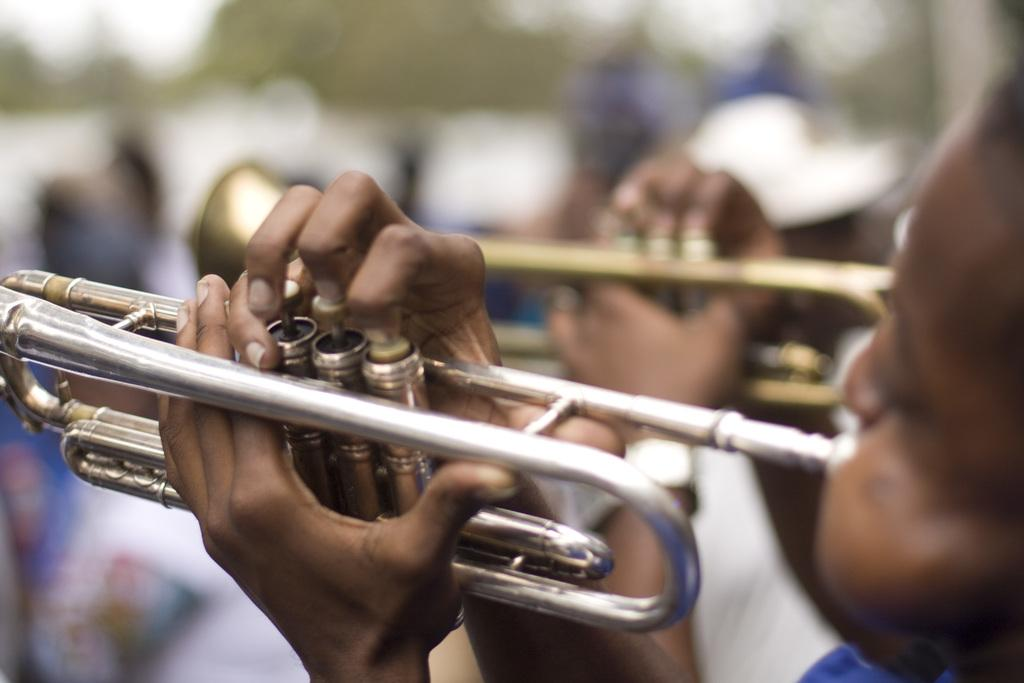How many people are in the image? There are two persons in the image. What are the two persons doing in the image? The two persons are playing trumpets. Can you describe the background of the image? The background of the image is blurry. What type of farm animals can be seen in the image? There are no farm animals present in the image. What color is the cart in the image? There is no cart present in the image. 